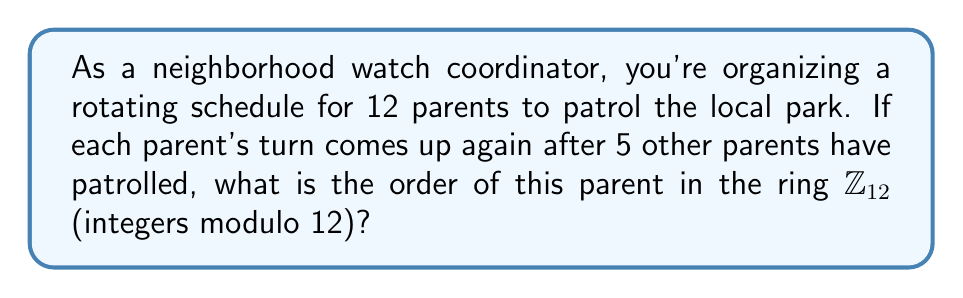Provide a solution to this math problem. Let's approach this step-by-step:

1) In ring theory, the order of an element $a$ in a finite ring $R$ is the smallest positive integer $n$ such that $na = 0$ in $R$.

2) In this case, we're working in the ring $\mathbb{Z}_{12}$, which consists of integers modulo 12.

3) Let's call our parent's position in the rotation $x$. We're told that after 5 other parents have patrolled, this parent's turn comes up again. This means:

   $x + 6 \equiv x \pmod{12}$

4) This is because the parent's original position plus 6 (5 other parents plus themselves) should be equivalent to their original position in modulo 12.

5) We can simplify this equation:

   $6 \equiv 0 \pmod{12}$

6) This means that 6 times the parent's "element" in the ring brings us back to 0.

7) To find the order, we need to find the smallest positive integer $n$ such that:

   $nx \equiv 0 \pmod{12}$

8) We've found that $n = 6$ works. We need to check if any smaller positive integer works:

   For $n = 1, 2, 3, 4, 5$: $nx \not\equiv 0 \pmod{12}$

9) Therefore, 6 is the smallest positive integer that satisfies the condition.
Answer: The order of the element representing the parent in $\mathbb{Z}_{12}$ is 6. 